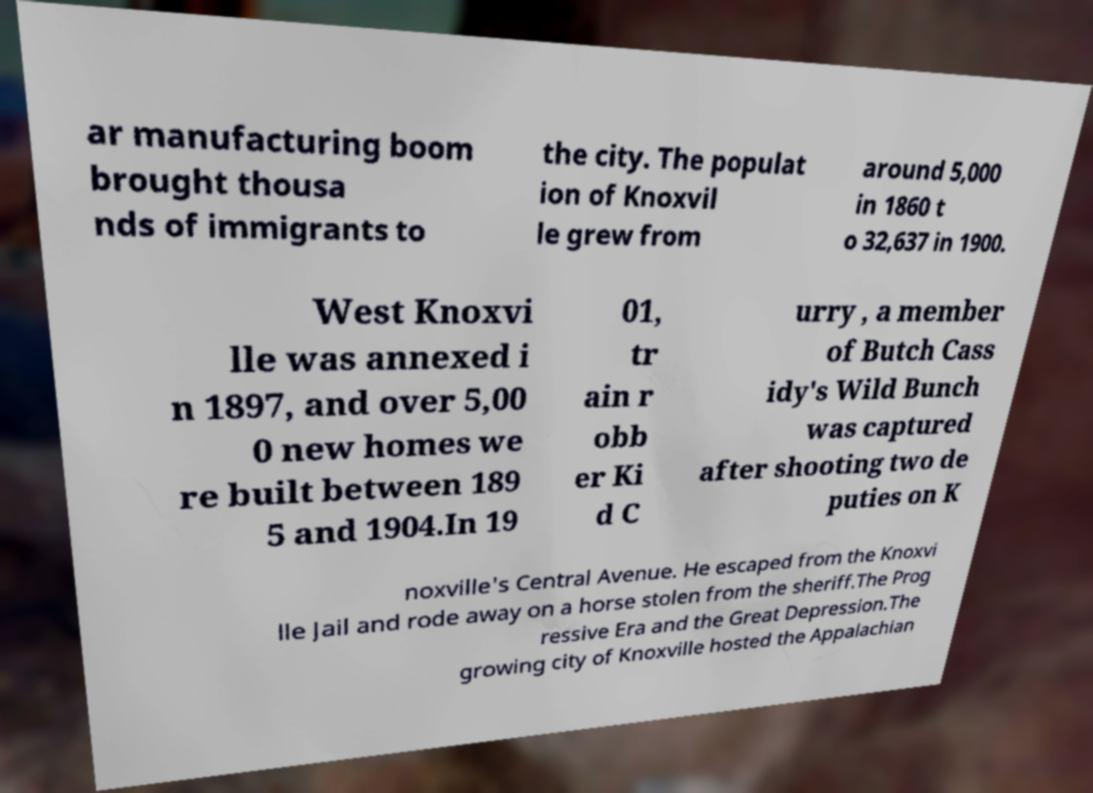There's text embedded in this image that I need extracted. Can you transcribe it verbatim? ar manufacturing boom brought thousa nds of immigrants to the city. The populat ion of Knoxvil le grew from around 5,000 in 1860 t o 32,637 in 1900. West Knoxvi lle was annexed i n 1897, and over 5,00 0 new homes we re built between 189 5 and 1904.In 19 01, tr ain r obb er Ki d C urry , a member of Butch Cass idy's Wild Bunch was captured after shooting two de puties on K noxville's Central Avenue. He escaped from the Knoxvi lle Jail and rode away on a horse stolen from the sheriff.The Prog ressive Era and the Great Depression.The growing city of Knoxville hosted the Appalachian 